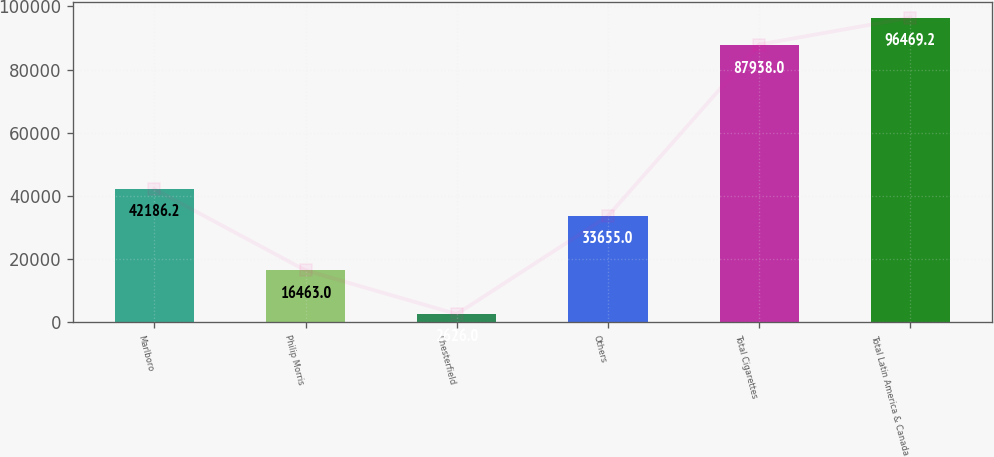<chart> <loc_0><loc_0><loc_500><loc_500><bar_chart><fcel>Marlboro<fcel>Philip Morris<fcel>Chesterfield<fcel>Others<fcel>Total Cigarettes<fcel>Total Latin America & Canada<nl><fcel>42186.2<fcel>16463<fcel>2626<fcel>33655<fcel>87938<fcel>96469.2<nl></chart> 